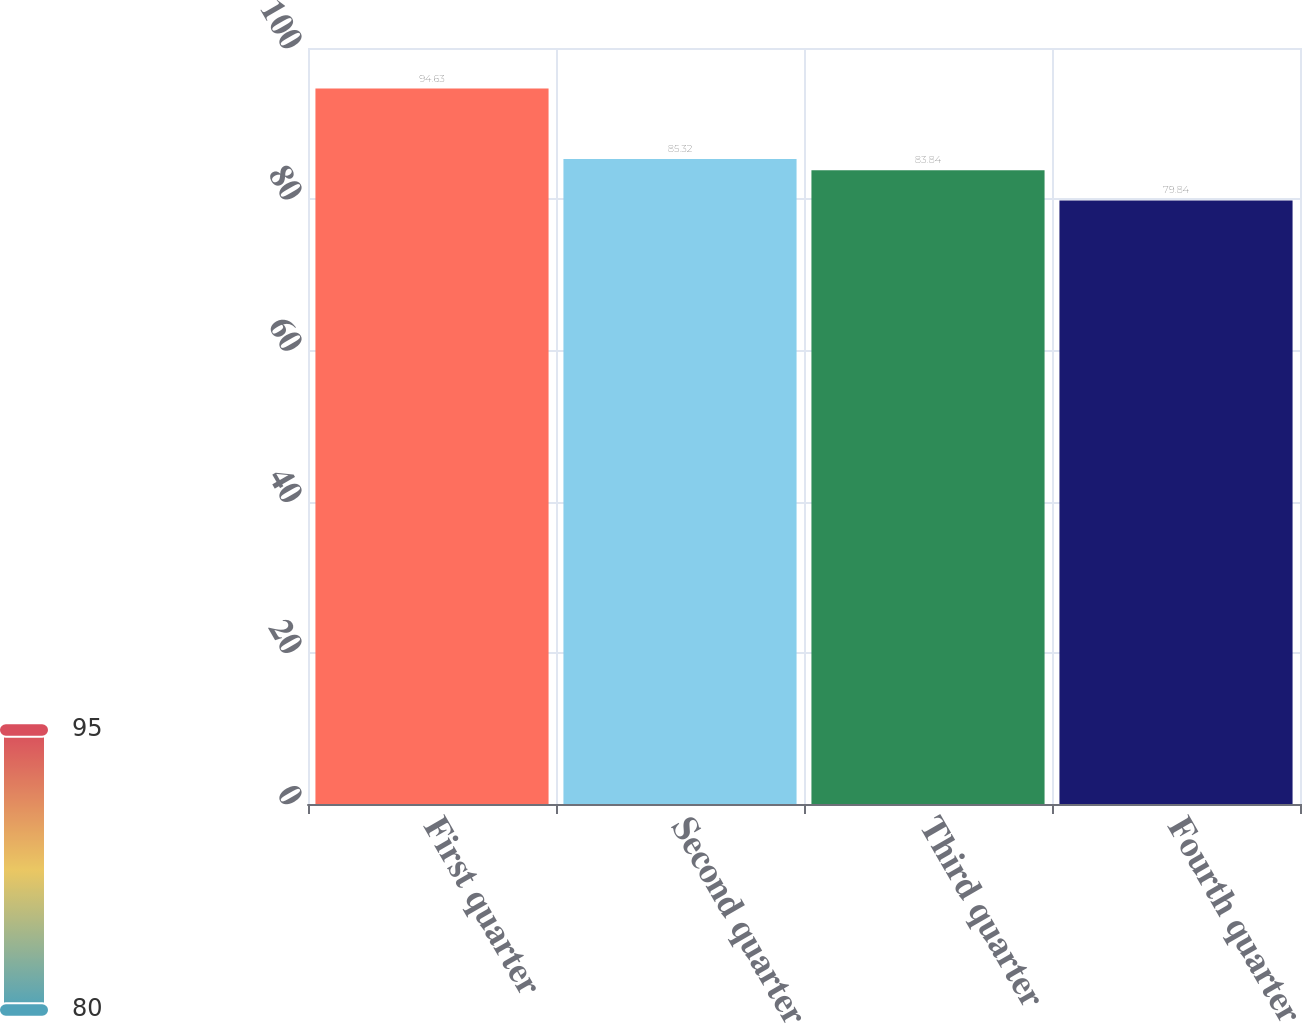Convert chart to OTSL. <chart><loc_0><loc_0><loc_500><loc_500><bar_chart><fcel>First quarter<fcel>Second quarter<fcel>Third quarter<fcel>Fourth quarter<nl><fcel>94.63<fcel>85.32<fcel>83.84<fcel>79.84<nl></chart> 